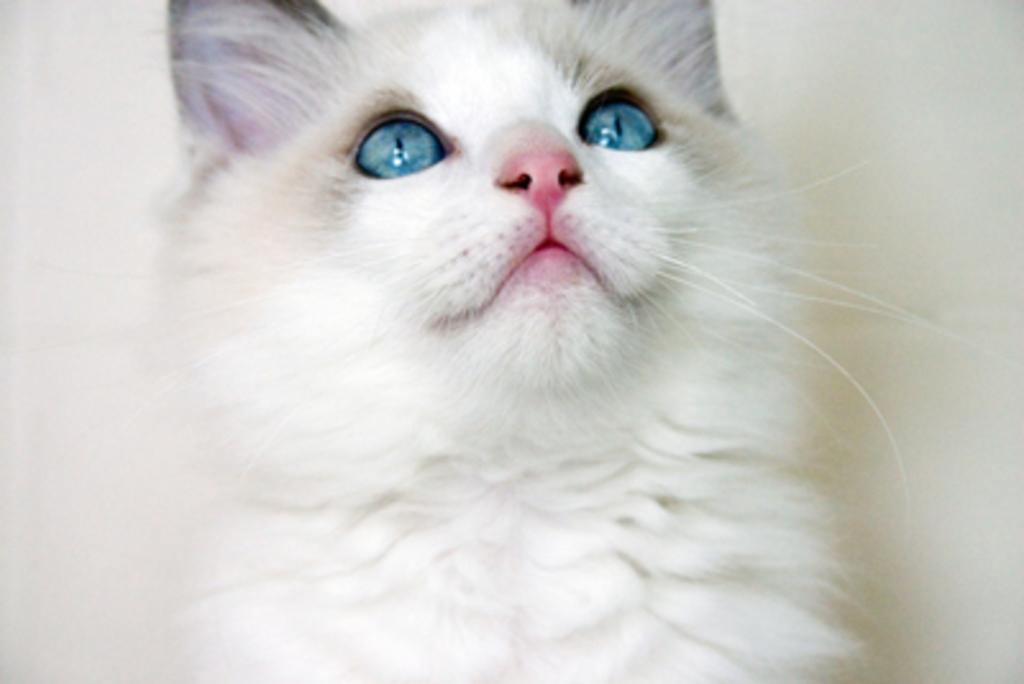What type of animal is in the image? There is a white color cat in the image. What is the cat doing in the image? The cat is looking at the top. What type of lettuce is the cat eating in the image? There is no lettuce present in the image, and the cat is not eating anything. 